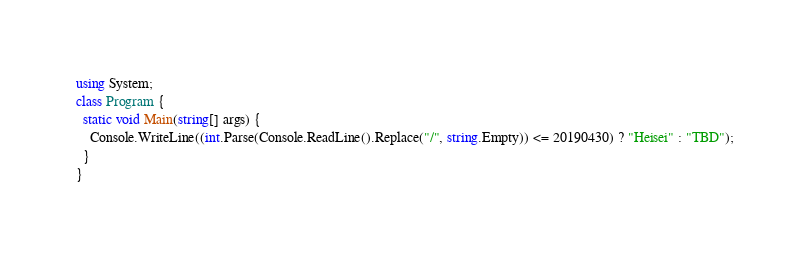Convert code to text. <code><loc_0><loc_0><loc_500><loc_500><_C#_>using System;
class Program {
  static void Main(string[] args) {
    Console.WriteLine((int.Parse(Console.ReadLine().Replace("/", string.Empty)) <= 20190430) ? "Heisei" : "TBD");
  }
}
</code> 